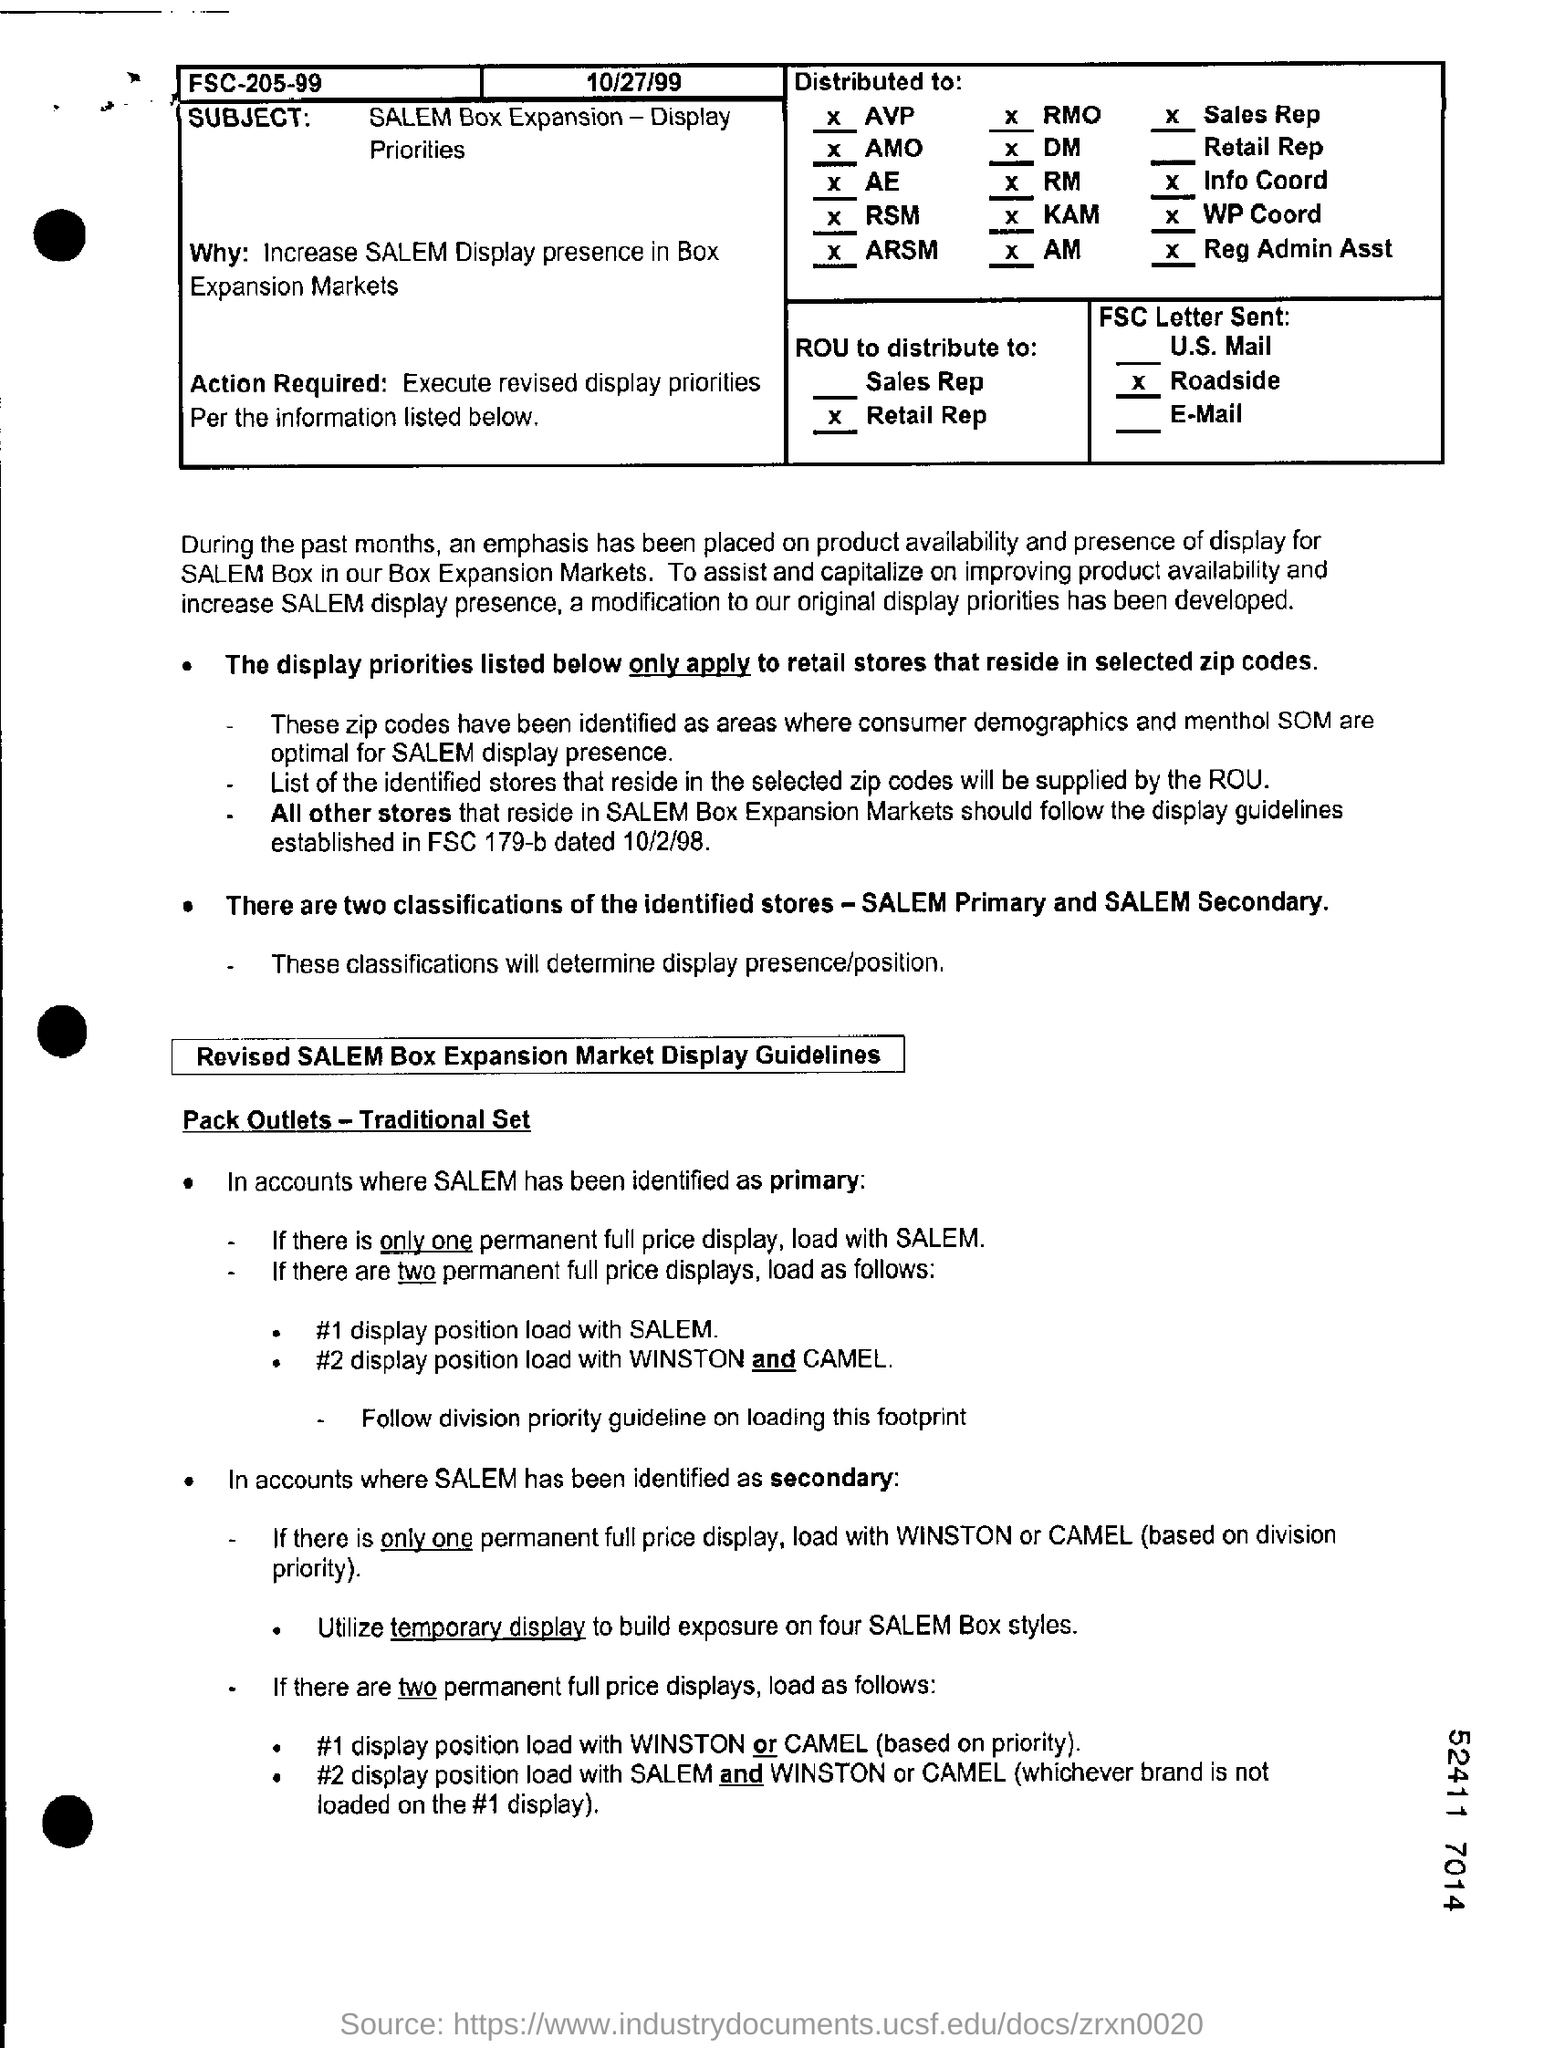Draw attention to some important aspects in this diagram. The date mentioned is October 27, 1999. SALEM primary and secondary classifications identify stores based on their characteristics and purposes. The subject of the sentence is SALEM Box Expansion - Display Priorities. 